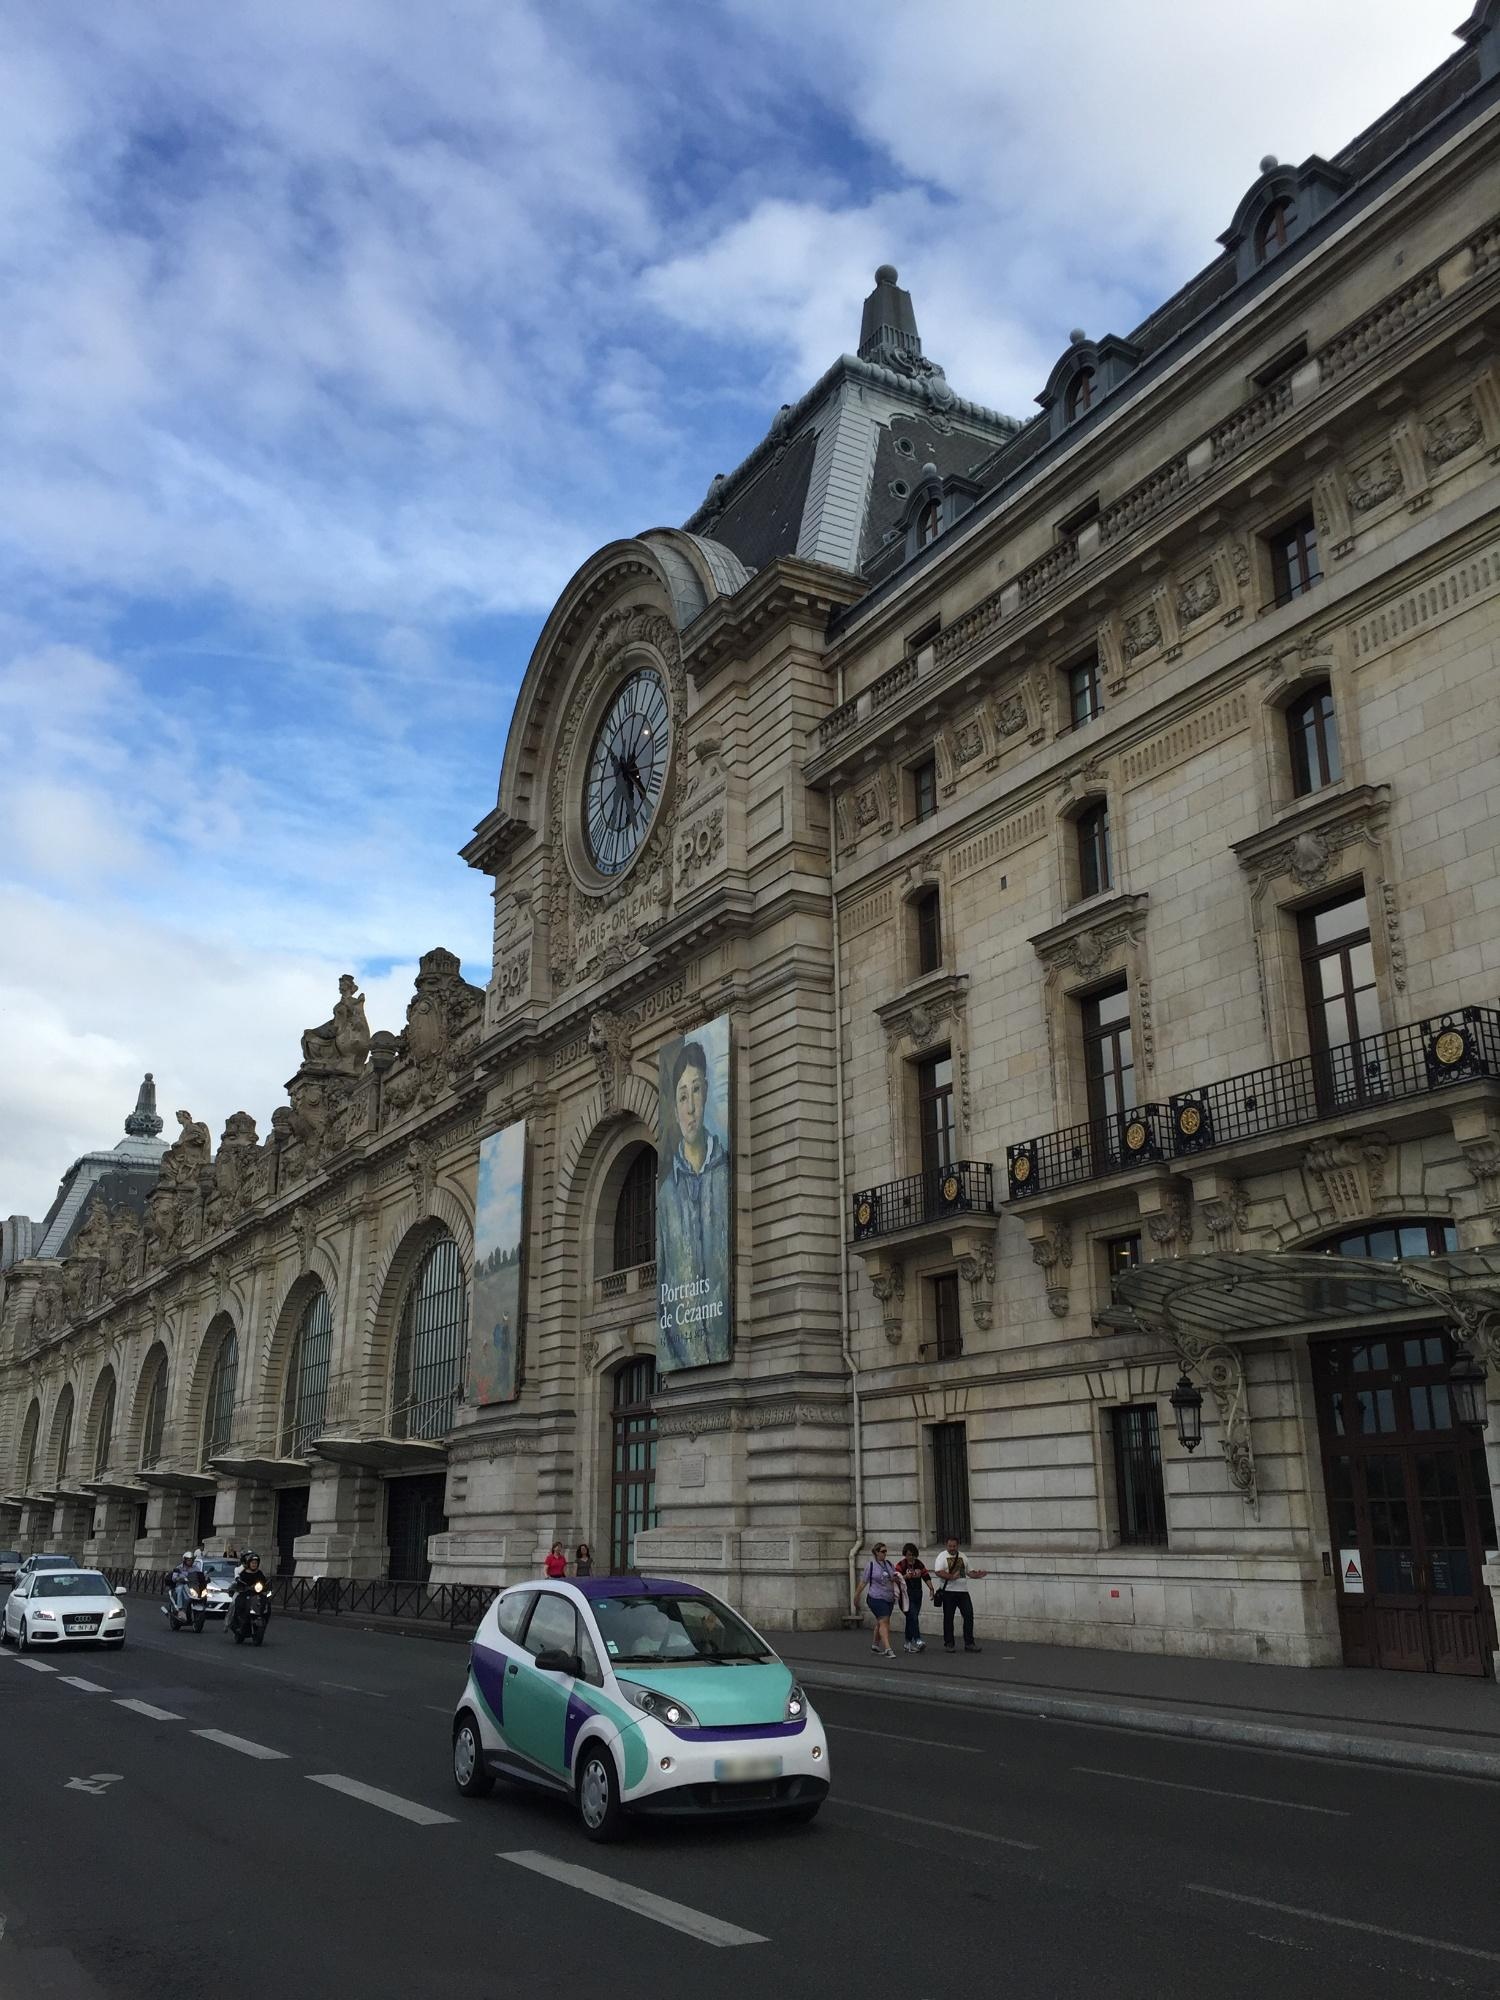What are the key elements in this picture? The image showcases the Musée d'Orsay in Paris, France, a striking example of Beaux-Arts architecture converted from a former railway station. Noteworthy features include the large central clock and intricate stonework of the facade, reflecting the building's historical heritage. The museum's location along the Seine River adds to its scenic and cultural importance. The bustling foreground with people and vehicles highlights the museum's role as an active hub in the city, inviting visitors and locals alike. Current exhibitions, such as 'Portraits de Cézanne' visible on banners, suggest ongoing events contributing to the museum's vibrant cultural life. 